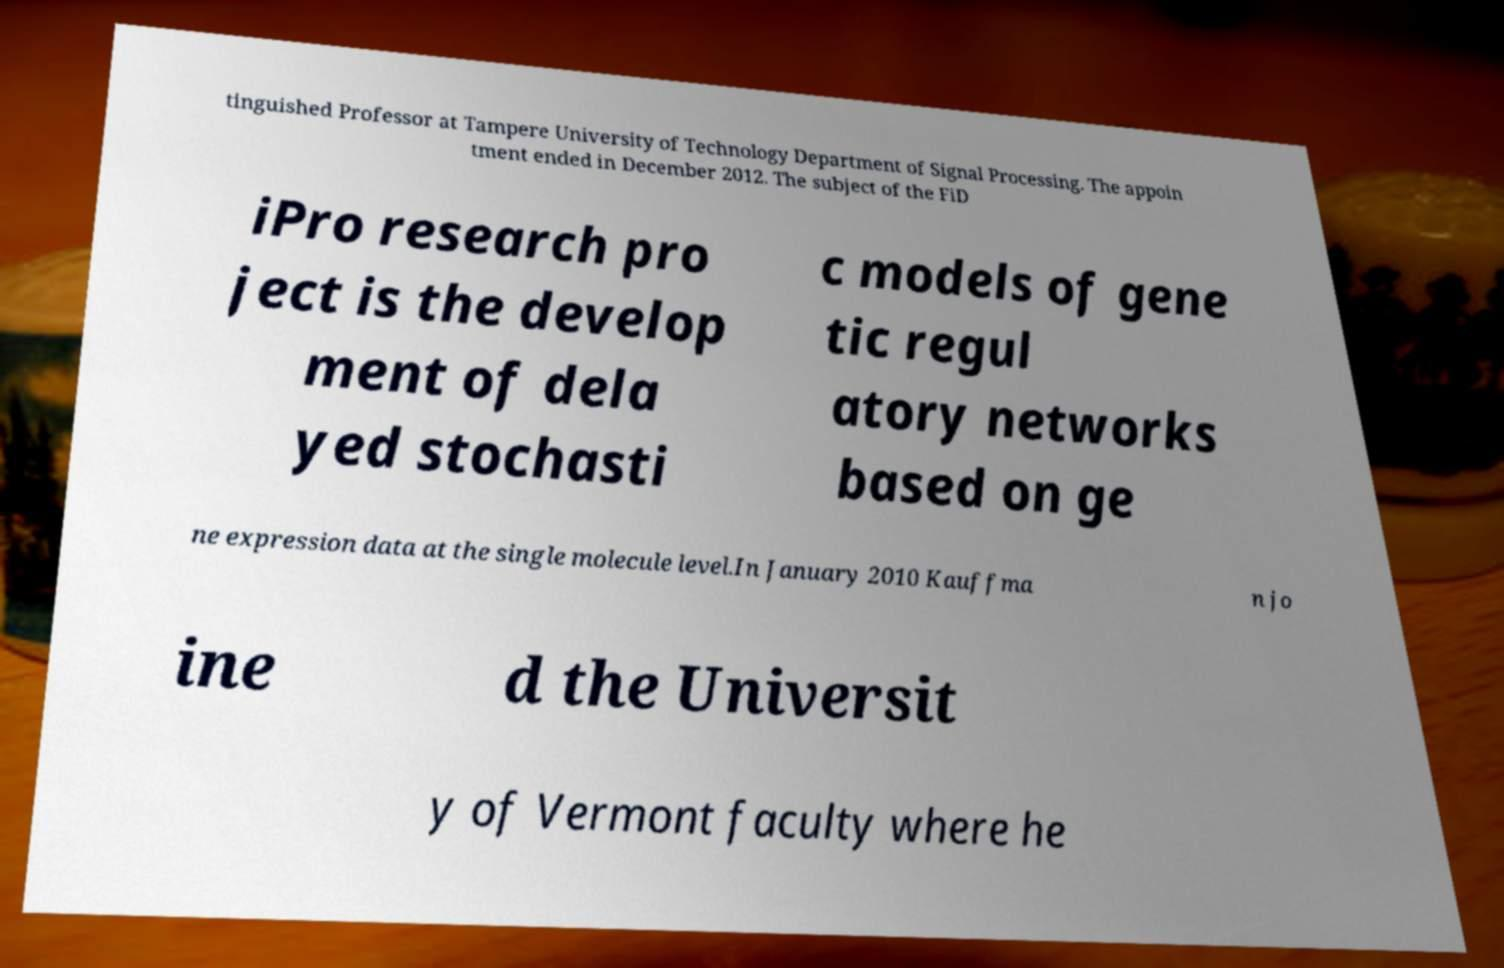Can you read and provide the text displayed in the image?This photo seems to have some interesting text. Can you extract and type it out for me? tinguished Professor at Tampere University of Technology Department of Signal Processing. The appoin tment ended in December 2012. The subject of the FiD iPro research pro ject is the develop ment of dela yed stochasti c models of gene tic regul atory networks based on ge ne expression data at the single molecule level.In January 2010 Kauffma n jo ine d the Universit y of Vermont faculty where he 